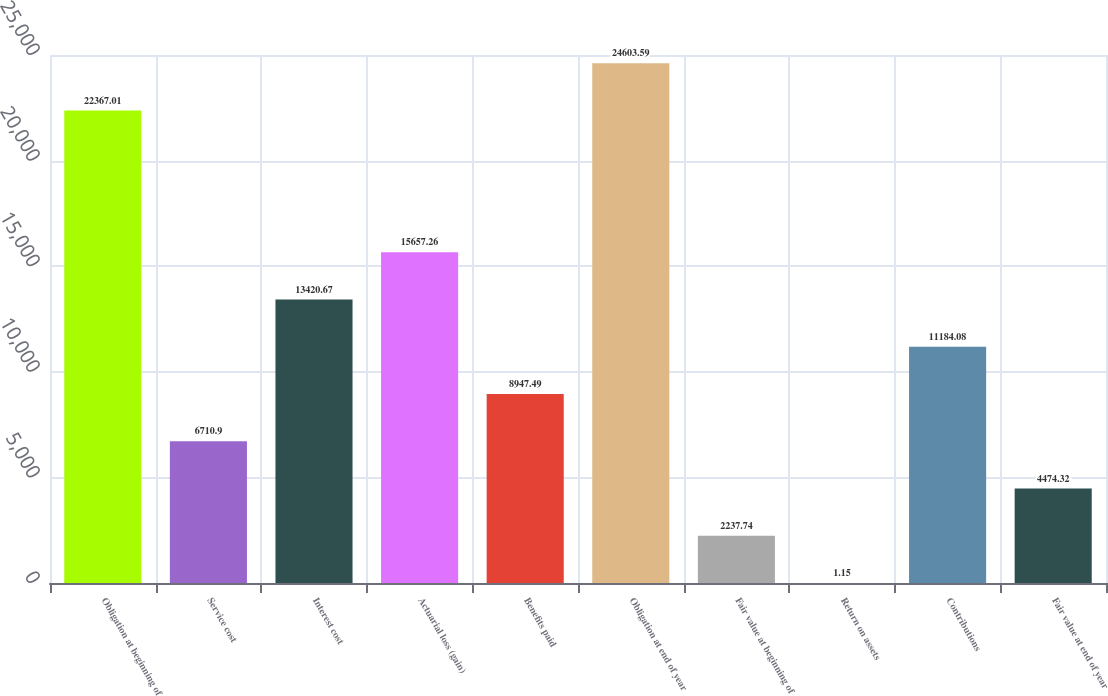<chart> <loc_0><loc_0><loc_500><loc_500><bar_chart><fcel>Obligation at beginning of<fcel>Service cost<fcel>Interest cost<fcel>Actuarial loss (gain)<fcel>Benefits paid<fcel>Obligation at end of year<fcel>Fair value at beginning of<fcel>Return on assets<fcel>Contributions<fcel>Fair value at end of year<nl><fcel>22367<fcel>6710.9<fcel>13420.7<fcel>15657.3<fcel>8947.49<fcel>24603.6<fcel>2237.74<fcel>1.15<fcel>11184.1<fcel>4474.32<nl></chart> 